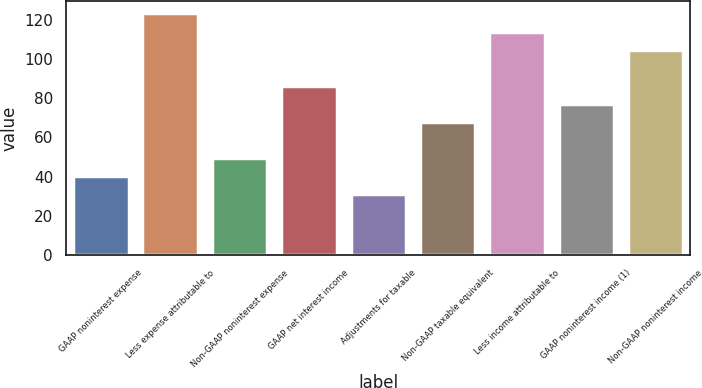<chart> <loc_0><loc_0><loc_500><loc_500><bar_chart><fcel>GAAP noninterest expense<fcel>Less expense attributable to<fcel>Non-GAAP noninterest expense<fcel>GAAP net interest income<fcel>Adjustments for taxable<fcel>Non-GAAP taxable equivalent<fcel>Less income attributable to<fcel>GAAP noninterest income (1)<fcel>Non-GAAP noninterest income<nl><fcel>40.34<fcel>123.23<fcel>49.55<fcel>86.39<fcel>31.13<fcel>67.97<fcel>114.02<fcel>77.18<fcel>104.81<nl></chart> 